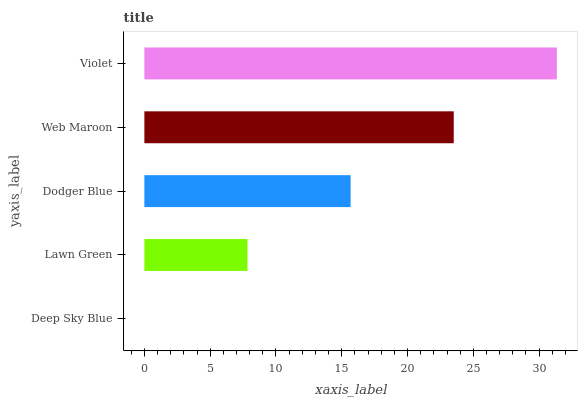Is Deep Sky Blue the minimum?
Answer yes or no. Yes. Is Violet the maximum?
Answer yes or no. Yes. Is Lawn Green the minimum?
Answer yes or no. No. Is Lawn Green the maximum?
Answer yes or no. No. Is Lawn Green greater than Deep Sky Blue?
Answer yes or no. Yes. Is Deep Sky Blue less than Lawn Green?
Answer yes or no. Yes. Is Deep Sky Blue greater than Lawn Green?
Answer yes or no. No. Is Lawn Green less than Deep Sky Blue?
Answer yes or no. No. Is Dodger Blue the high median?
Answer yes or no. Yes. Is Dodger Blue the low median?
Answer yes or no. Yes. Is Deep Sky Blue the high median?
Answer yes or no. No. Is Deep Sky Blue the low median?
Answer yes or no. No. 